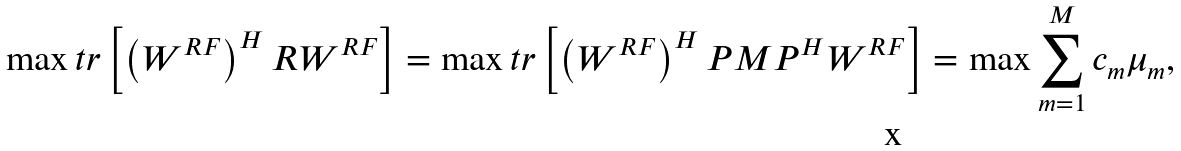<formula> <loc_0><loc_0><loc_500><loc_500>\max t r \left [ \left ( W ^ { R F } \right ) ^ { H } R W ^ { R F } \right ] = \max t r \left [ \left ( W ^ { R F } \right ) ^ { H } P M P ^ { H } W ^ { R F } \right ] = \max \sum _ { m = 1 } ^ { M } c _ { m } \mu _ { m } ,</formula> 